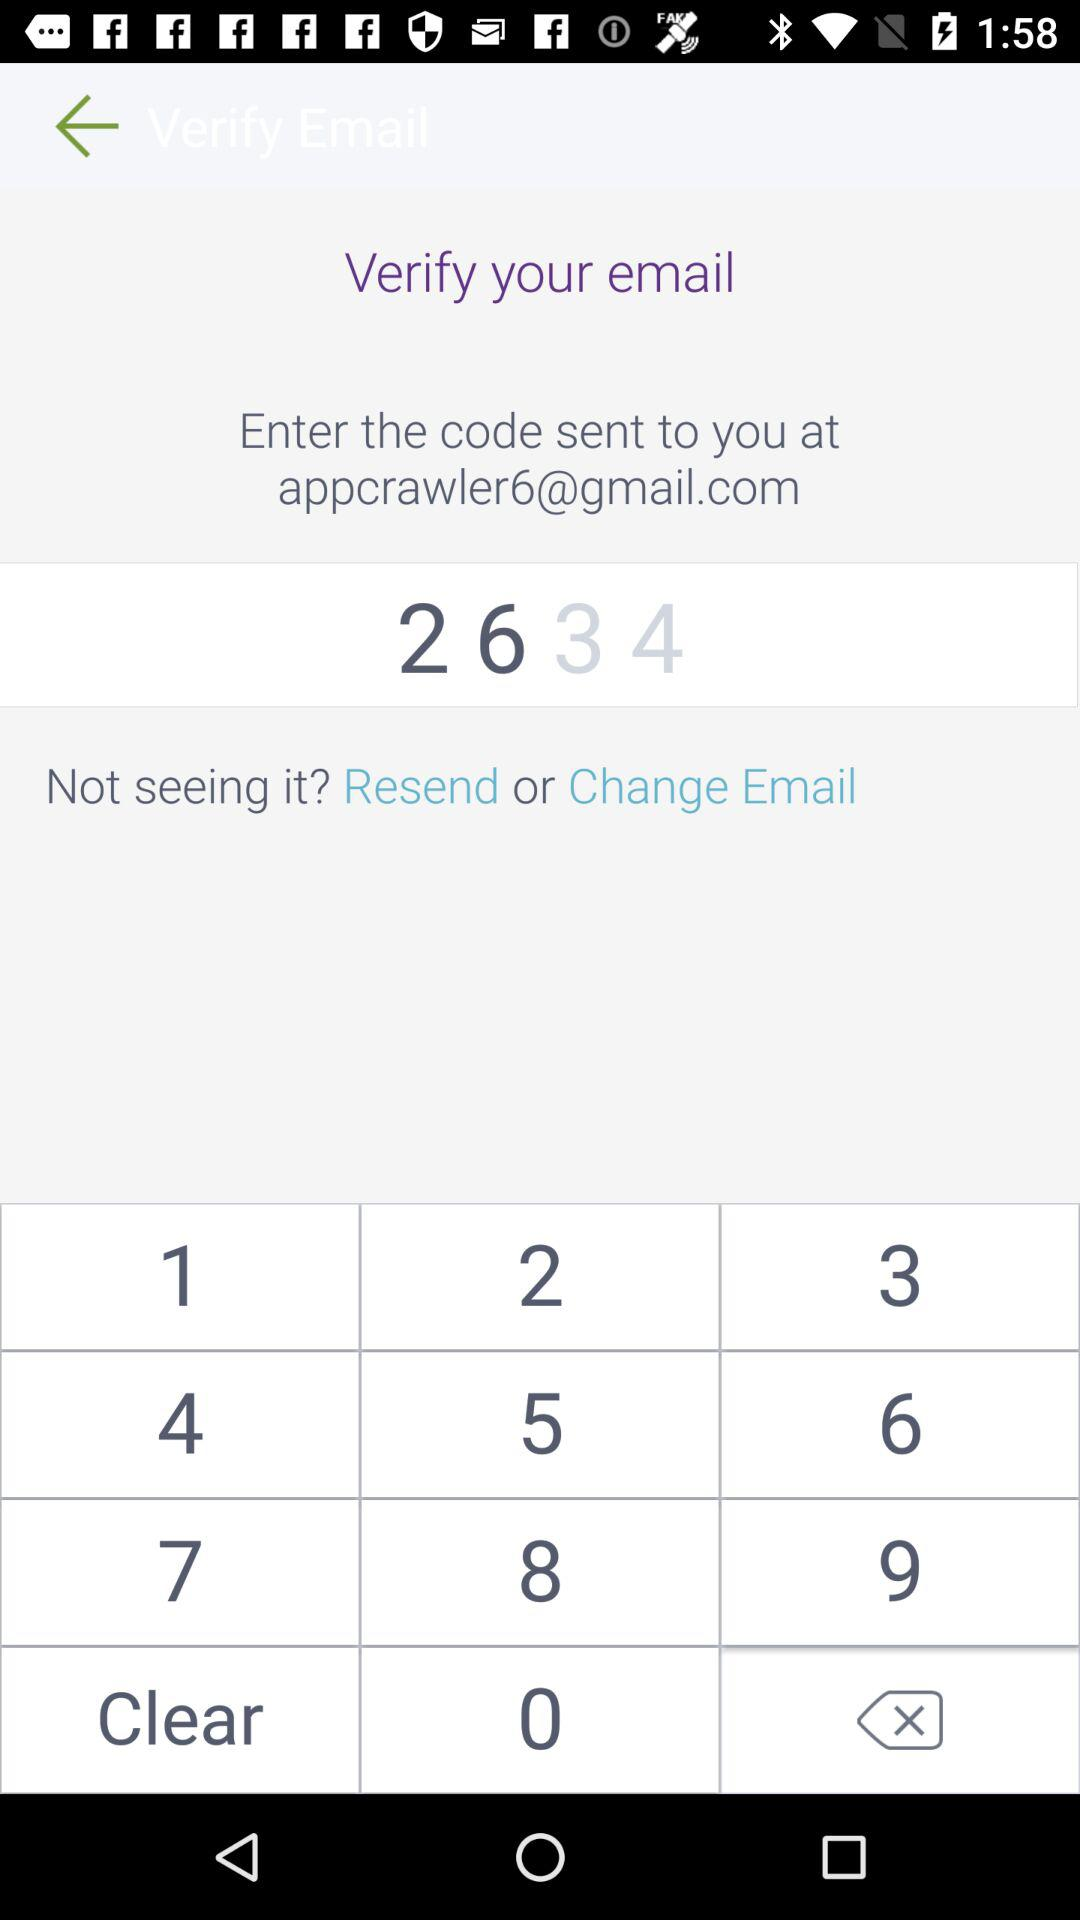What's the code? The code is 2634. 